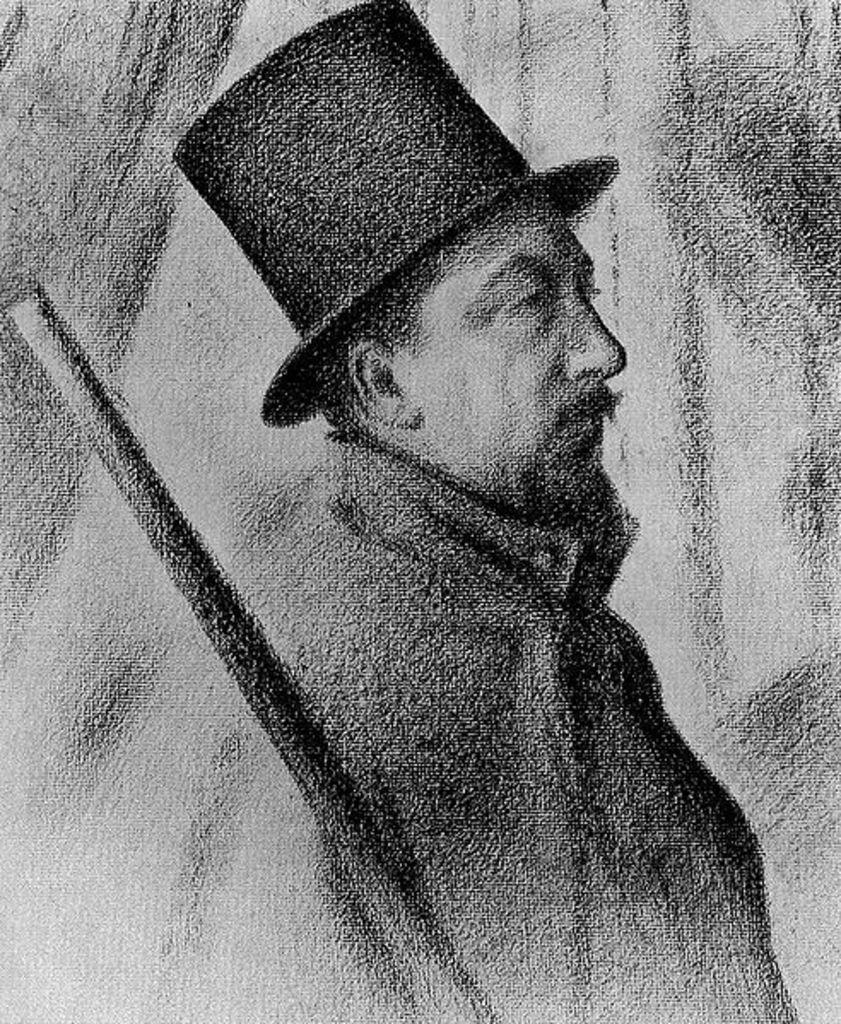What is the color scheme of the image? The image is black and white. Who is present in the image? There is a man in the image. What is the man wearing on his head? The man is wearing a hat. What object can be seen in the image besides the man? There is a stick in the image. What time of day is depicted in the image? The image does not provide any information about the time of day, as it is black and white and does not include any contextual clues. 